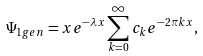Convert formula to latex. <formula><loc_0><loc_0><loc_500><loc_500>\Psi _ { 1 g e n } = x e ^ { - \lambda x } \sum _ { k = 0 } ^ { \infty } c _ { k } e ^ { - 2 \pi k x } ,</formula> 